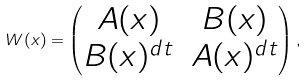<formula> <loc_0><loc_0><loc_500><loc_500>W ( x ) = \begin{pmatrix} A ( x ) & B ( x ) \\ B ( x ) ^ { d t } & A ( x ) ^ { d t } \end{pmatrix} ,</formula> 